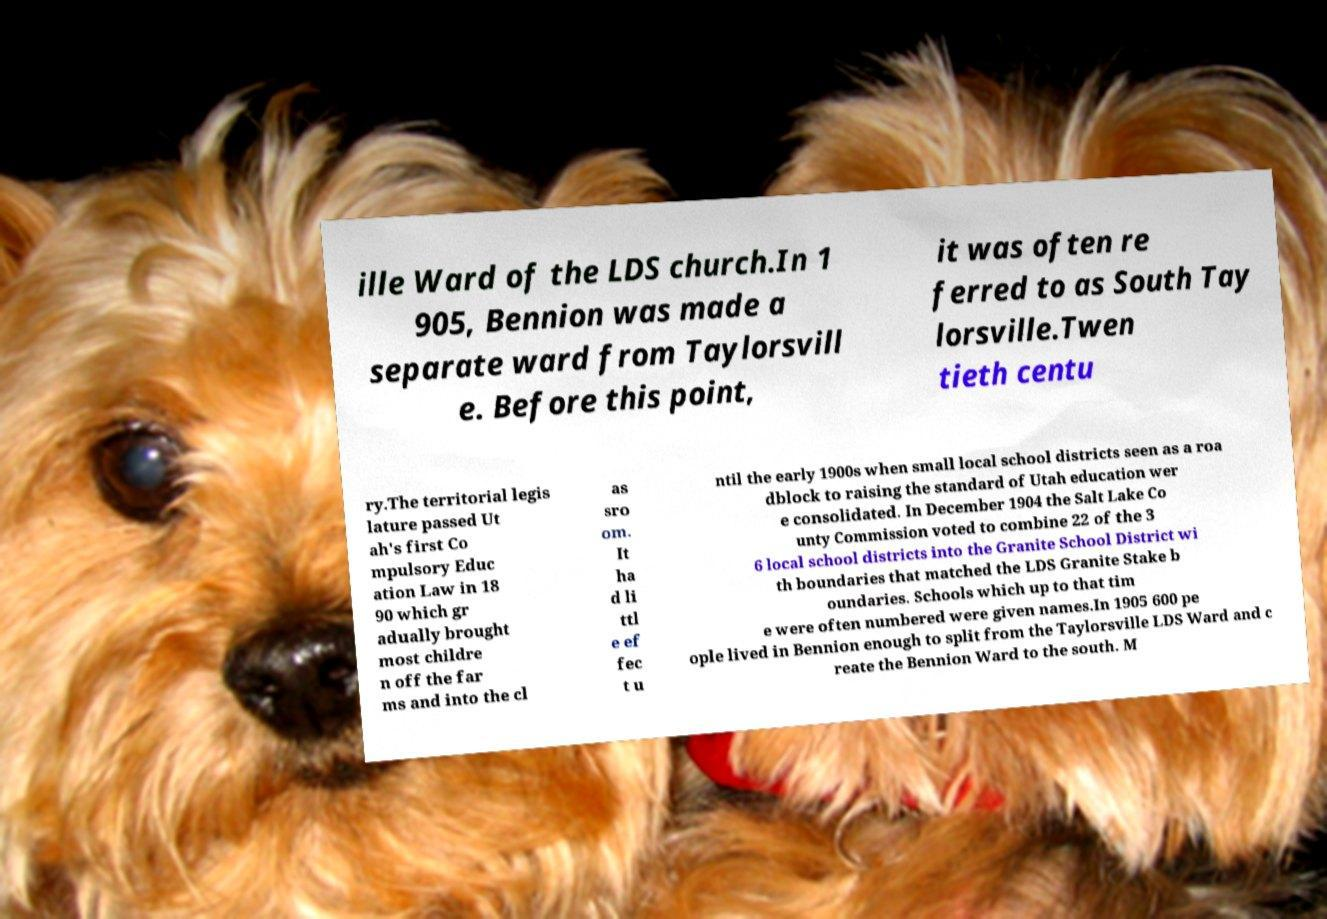Please read and relay the text visible in this image. What does it say? ille Ward of the LDS church.In 1 905, Bennion was made a separate ward from Taylorsvill e. Before this point, it was often re ferred to as South Tay lorsville.Twen tieth centu ry.The territorial legis lature passed Ut ah's first Co mpulsory Educ ation Law in 18 90 which gr adually brought most childre n off the far ms and into the cl as sro om. It ha d li ttl e ef fec t u ntil the early 1900s when small local school districts seen as a roa dblock to raising the standard of Utah education wer e consolidated. In December 1904 the Salt Lake Co unty Commission voted to combine 22 of the 3 6 local school districts into the Granite School District wi th boundaries that matched the LDS Granite Stake b oundaries. Schools which up to that tim e were often numbered were given names.In 1905 600 pe ople lived in Bennion enough to split from the Taylorsville LDS Ward and c reate the Bennion Ward to the south. M 